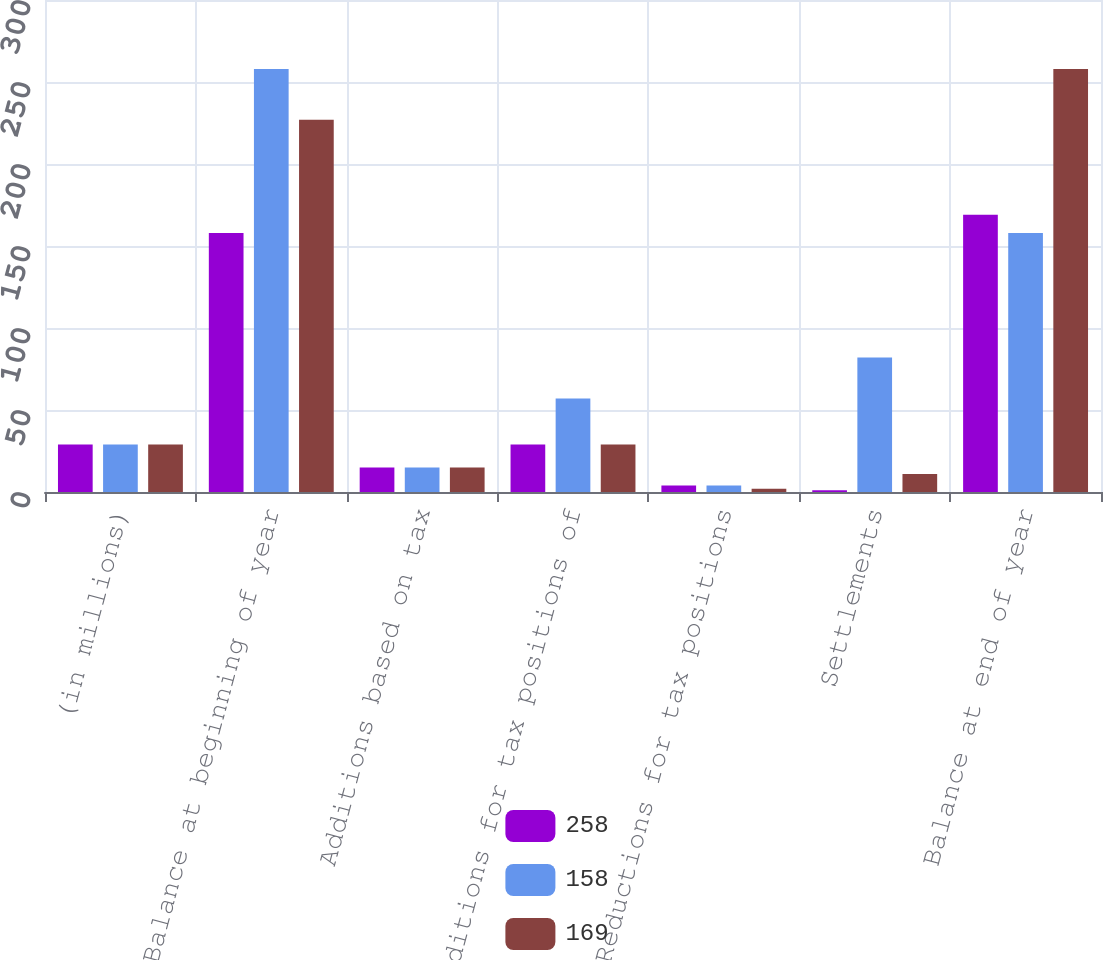Convert chart. <chart><loc_0><loc_0><loc_500><loc_500><stacked_bar_chart><ecel><fcel>(in millions)<fcel>Balance at beginning of year<fcel>Additions based on tax<fcel>Additions for tax positions of<fcel>Reductions for tax positions<fcel>Settlements<fcel>Balance at end of year<nl><fcel>258<fcel>29<fcel>158<fcel>15<fcel>29<fcel>4<fcel>1<fcel>169<nl><fcel>158<fcel>29<fcel>258<fcel>15<fcel>57<fcel>4<fcel>82<fcel>158<nl><fcel>169<fcel>29<fcel>227<fcel>15<fcel>29<fcel>2<fcel>11<fcel>258<nl></chart> 